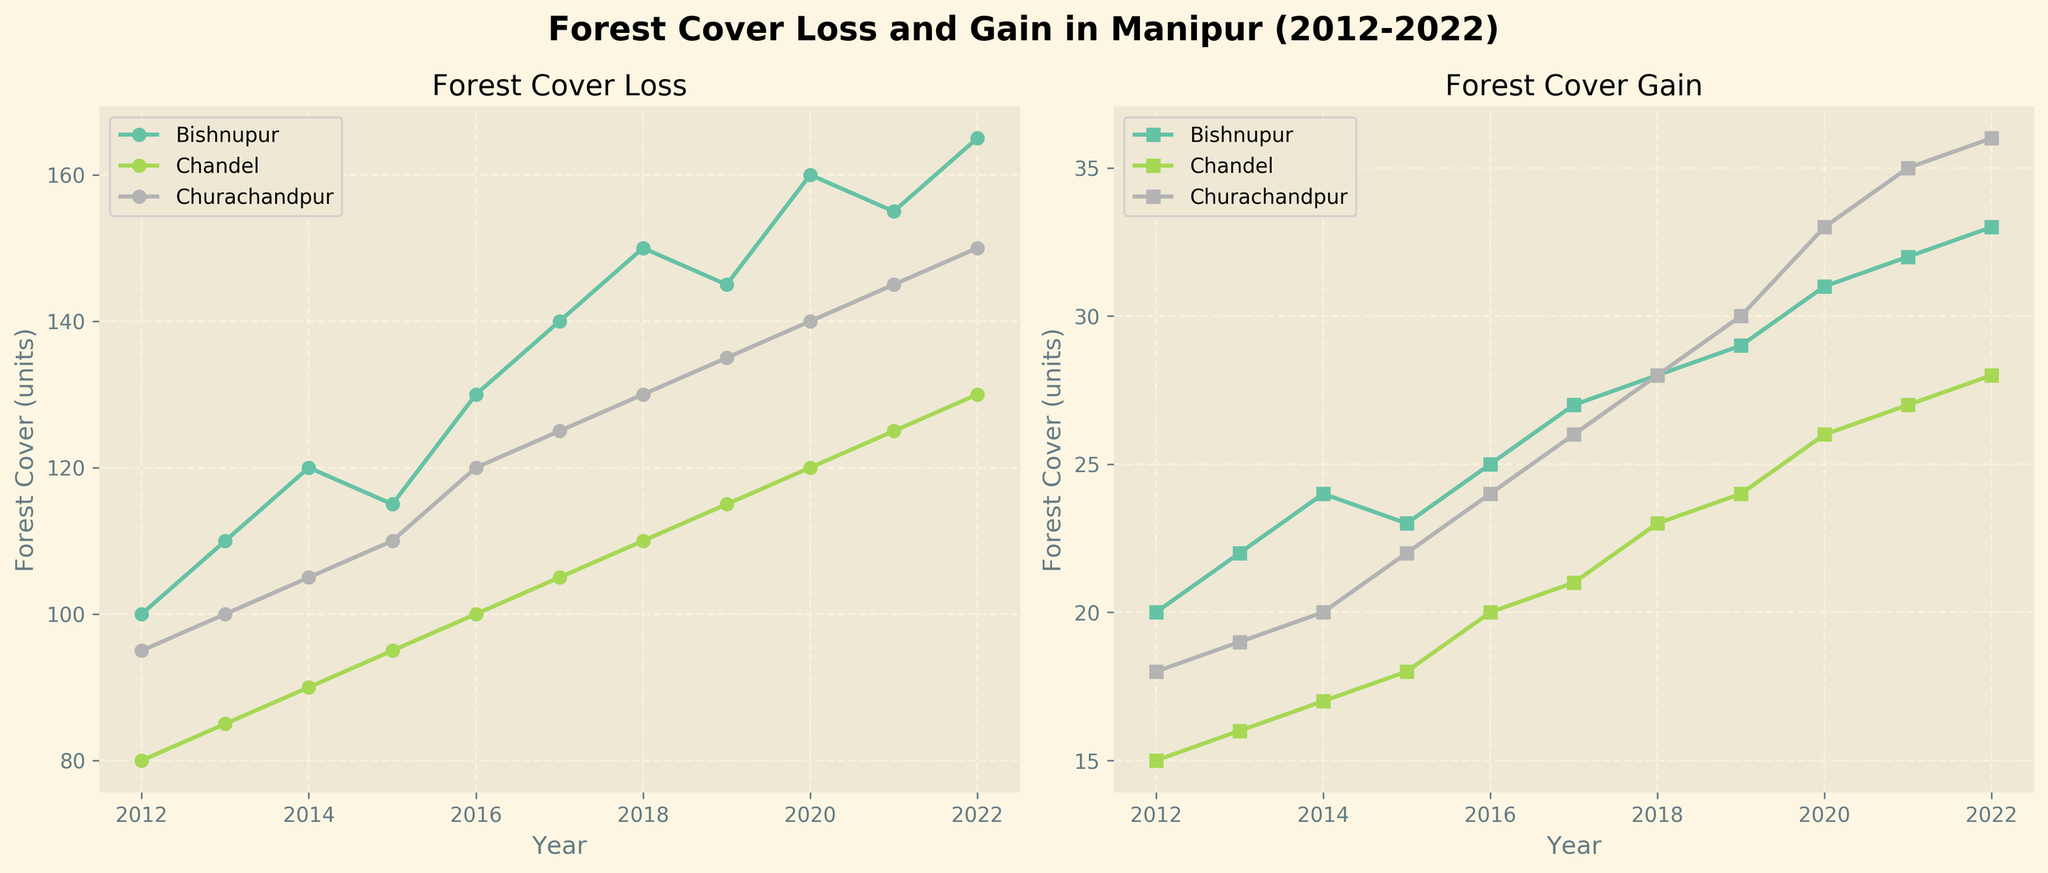What is the title of the figure? The title is typically at the top and specifies the main topic. In the figure, the title states "Forest Cover Loss and Gain in Manipur (2012-2022)."
Answer: Forest Cover Loss and Gain in Manipur (2012-2022) Which region had the highest forest cover loss in 2022? Look at the 'Forest Cover Loss' subplot for the year 2022 and compare the values for Bishnupur, Chandel, and Churachandpur. Bishnupur had the highest value.
Answer: Bishnupur How does forest cover gain in Churachandpur in 2020 compare to Bishnupur in the same year? Locate the year 2020 on the 'Forest Cover Gain' subplot for both Churachandpur and Bishnupur. Churachandpur gains 33 units, while Bishnupur gains 31 units.
Answer: Churachandpur has more gain What is the total forest cover gain across all regions in 2017? Sum up the forest cover gain for Bishnupur, Chandel, and Churachandpur in 2017 from the 'Forest Cover Gain' subplot: 27 + 21 + 26 = 74 units.
Answer: 74 units Which year had the lowest overall forest cover loss for Chandel? Identify the values for Chandel across all years in the 'Forest Cover Loss' subplot and find the smallest one. The lowest value is in 2012 at 80 units.
Answer: 2012 What trend can be observed in forest cover loss in Bishnupur from 2012 to 2022? Observe the line for Bishnupur in the 'Forest Cover Loss' subplot. It shows an increasing trend over the years.
Answer: Increasing trend How much did forest cover gain change in Churachandpur from 2012 to 2022? Look at the 'Forest Cover Gain' subplot for Churachandpur in both 2012 (18 units) and 2022 (36 units). The change is 36 - 18 = 18 units.
Answer: Increased by 18 units Which region shows the most stable forest cover loss over the decade? Compare the fluctuation of data points in the 'Forest Cover Loss' subplot for all three regions. Chandel shows the least fluctuation.
Answer: Chandel What is the ratio of forest cover loss to gain in Bishnupur in 2019? In 2019, Bishnupur had a loss of 145 units and a gain of 29 units. The ratio is 145/29 ≈ 5.
Answer: 5 to 1 